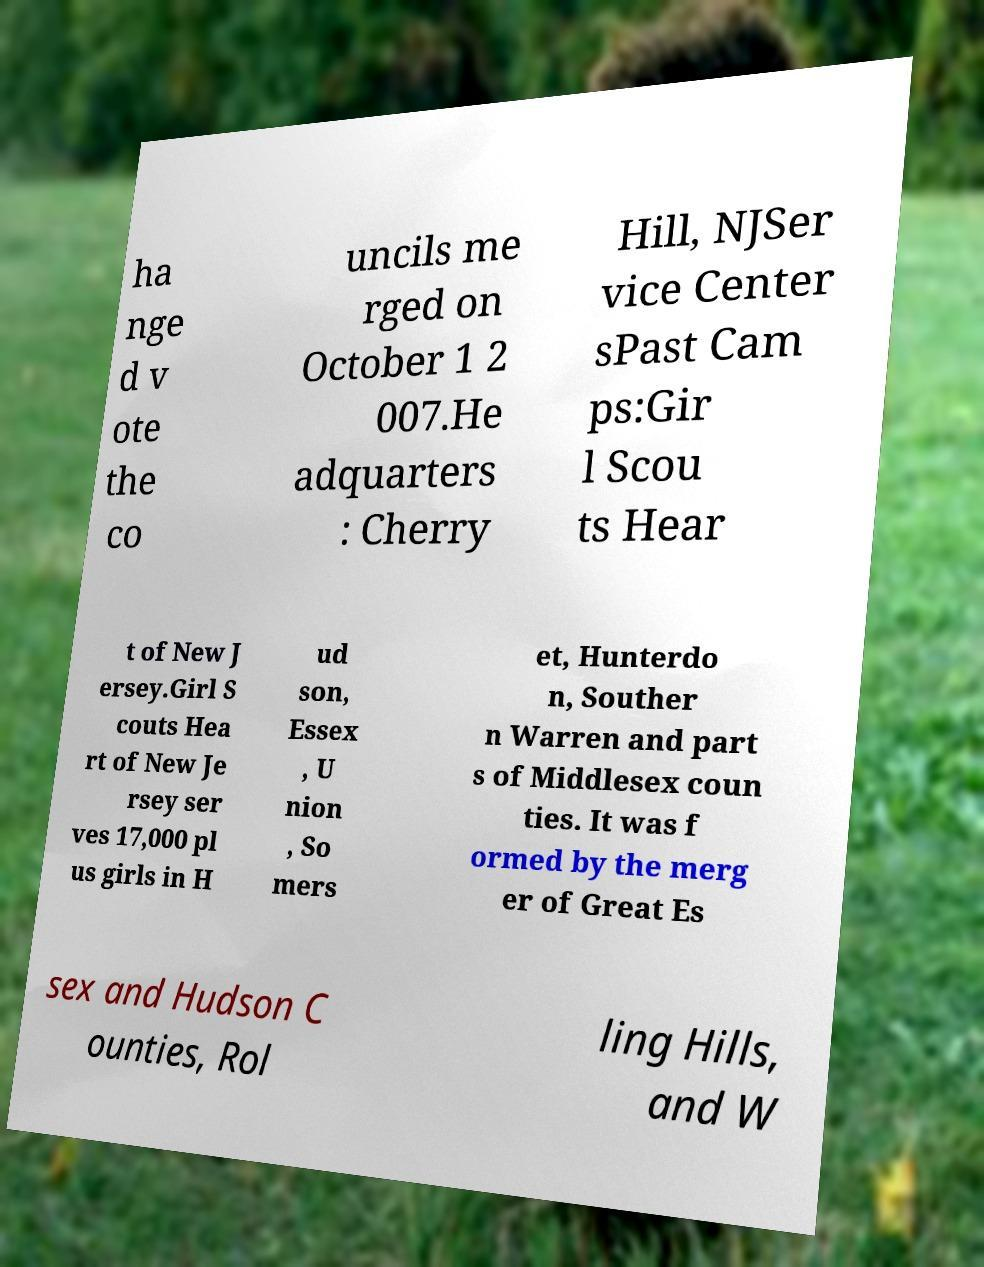Can you read and provide the text displayed in the image?This photo seems to have some interesting text. Can you extract and type it out for me? ha nge d v ote the co uncils me rged on October 1 2 007.He adquarters : Cherry Hill, NJSer vice Center sPast Cam ps:Gir l Scou ts Hear t of New J ersey.Girl S couts Hea rt of New Je rsey ser ves 17,000 pl us girls in H ud son, Essex , U nion , So mers et, Hunterdo n, Souther n Warren and part s of Middlesex coun ties. It was f ormed by the merg er of Great Es sex and Hudson C ounties, Rol ling Hills, and W 